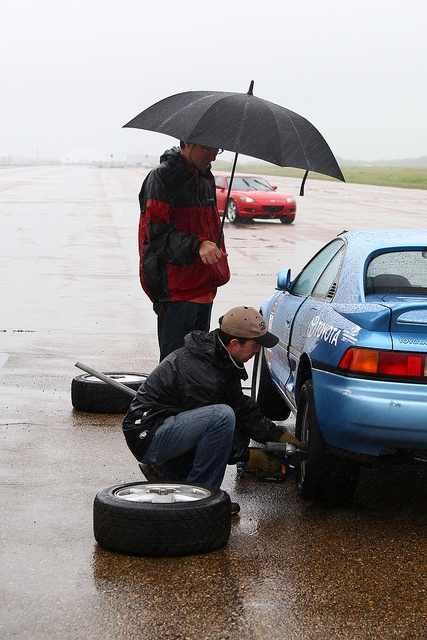Describe the objects in this image and their specific colors. I can see car in white, black, lightblue, and darkgray tones, people in white, black, gray, maroon, and lightgray tones, people in white, black, maroon, lightgray, and gray tones, umbrella in white, gray, and black tones, and car in white, black, lightgray, lightpink, and brown tones in this image. 